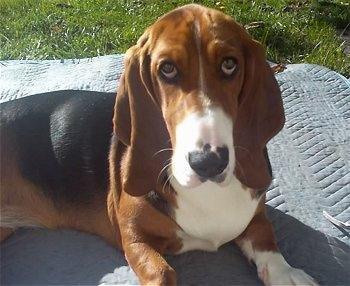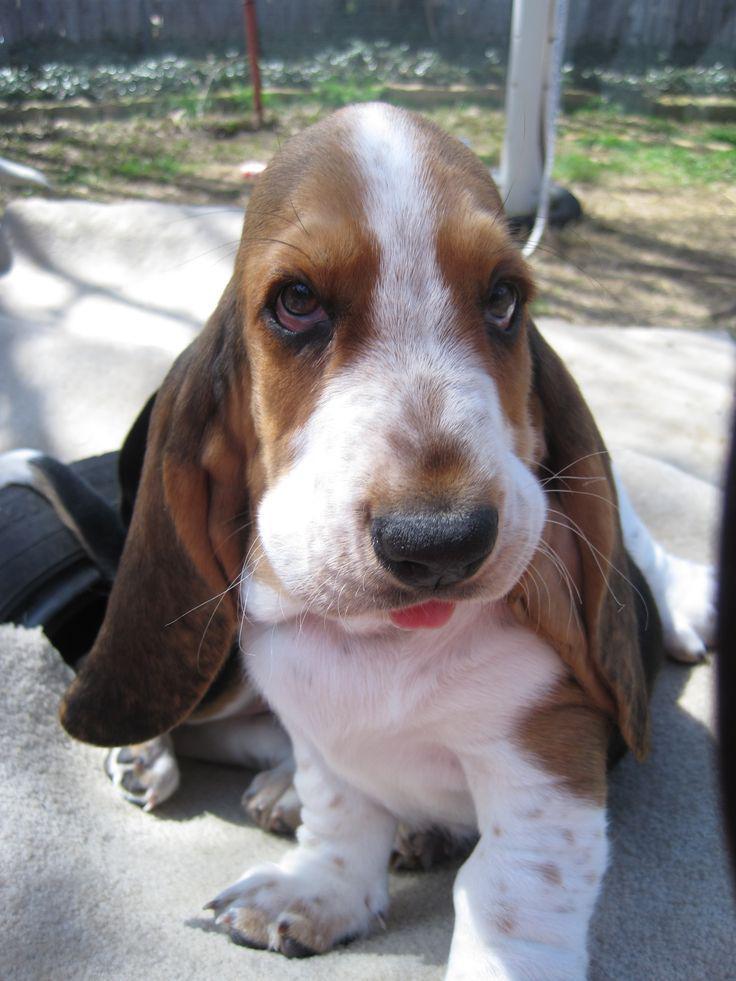The first image is the image on the left, the second image is the image on the right. Considering the images on both sides, is "At least one dog is standing on grass." valid? Answer yes or no. No. The first image is the image on the left, the second image is the image on the right. Assess this claim about the two images: "Two basset hounds face the camera and are not standing on grass.". Correct or not? Answer yes or no. Yes. 